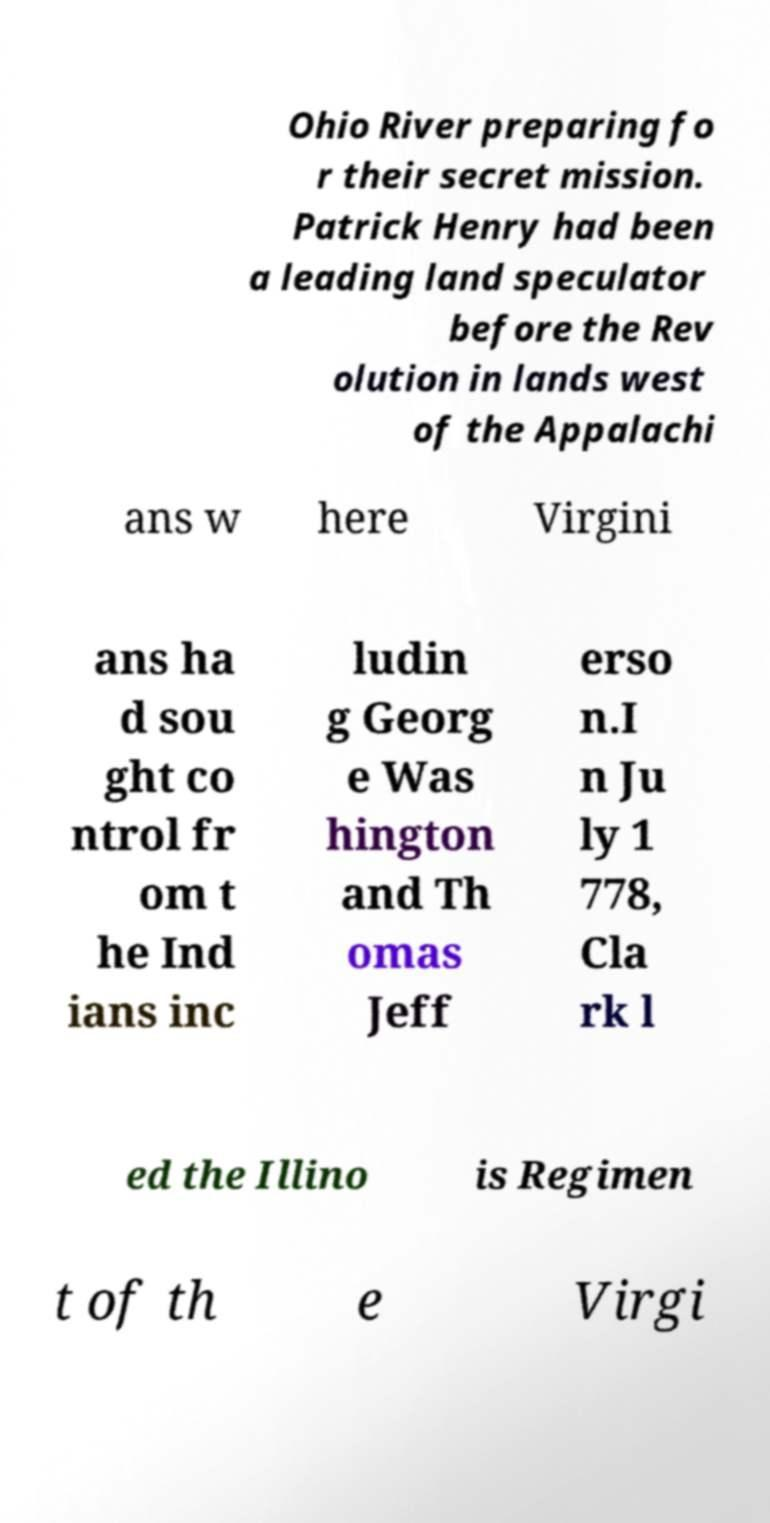What messages or text are displayed in this image? I need them in a readable, typed format. Ohio River preparing fo r their secret mission. Patrick Henry had been a leading land speculator before the Rev olution in lands west of the Appalachi ans w here Virgini ans ha d sou ght co ntrol fr om t he Ind ians inc ludin g Georg e Was hington and Th omas Jeff erso n.I n Ju ly 1 778, Cla rk l ed the Illino is Regimen t of th e Virgi 